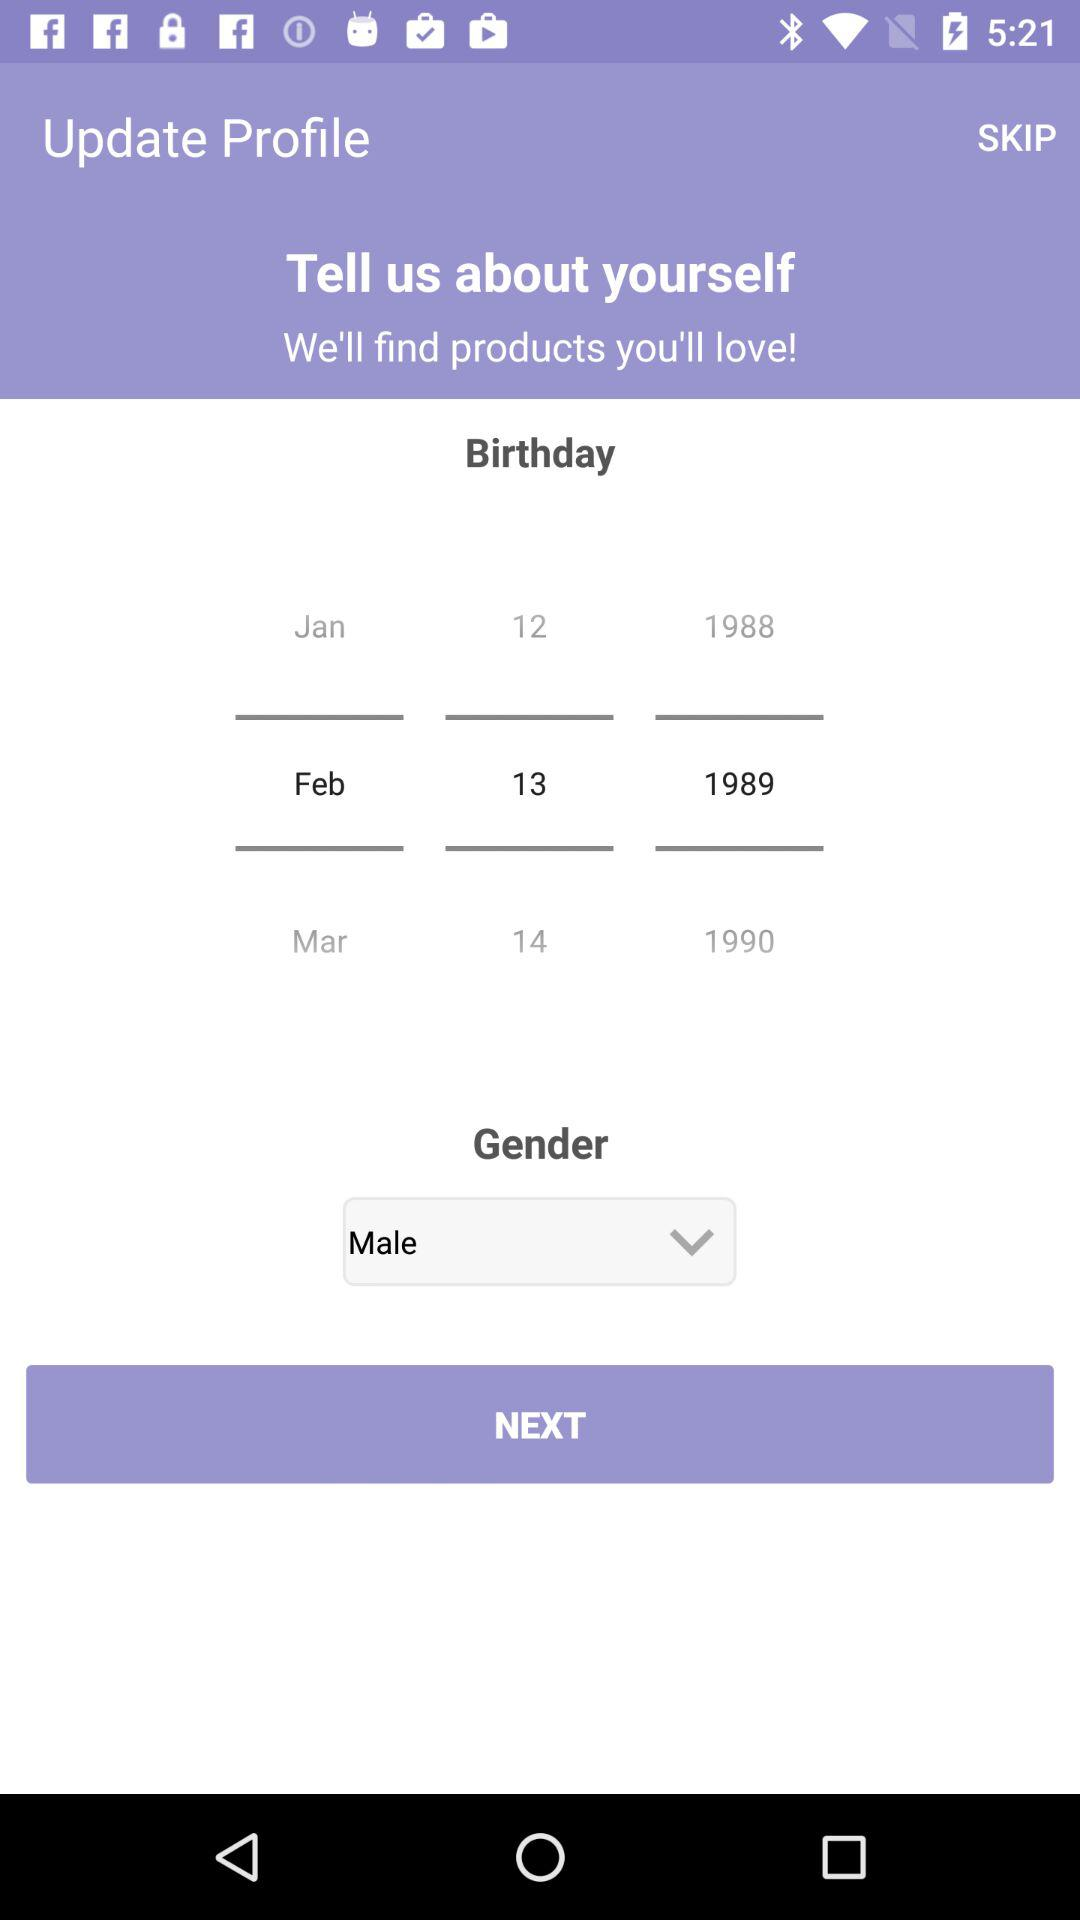What is the user's name?
When the provided information is insufficient, respond with <no answer>. <no answer> 